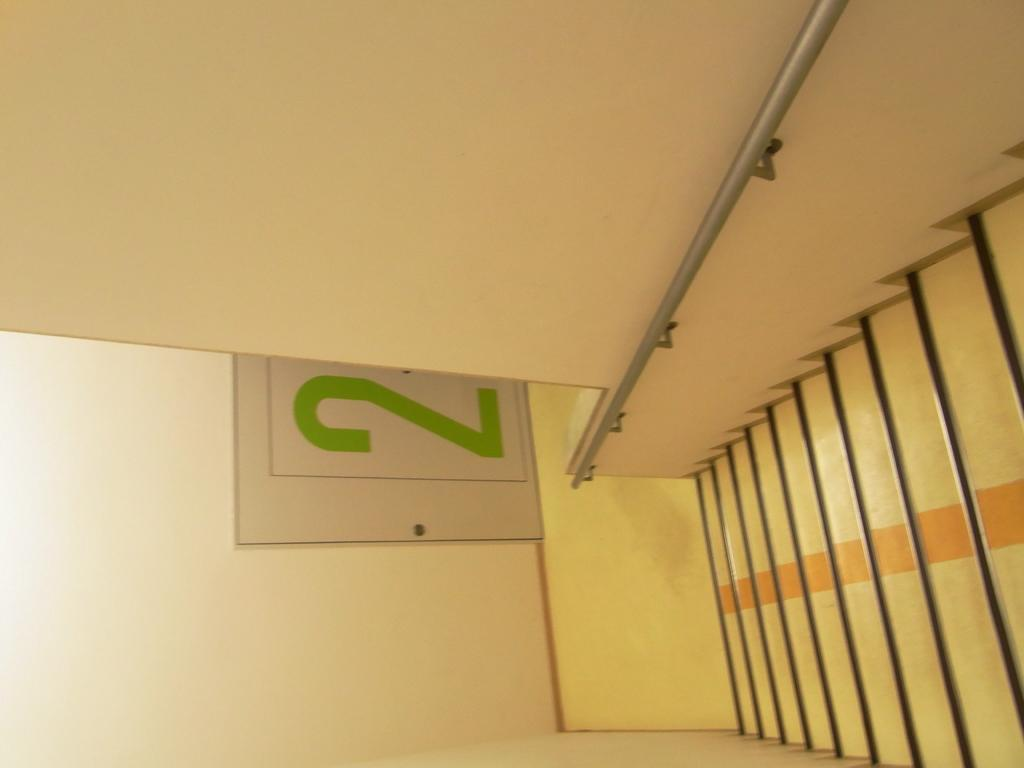What type of structure is present in the image? There is a stair in the image. Is there any support for the stair in the image? Yes, there is a handrail attached to the wall in the image. What else can be seen attached to the wall in the image? There is a board with a number on it in the image. How is the board with a number attached to the wall? The board is attached to the wall. What type of dinner is being served on the railway in the image? There is no dinner or railway present in the image; it only features a stair, handrail, and board with a number. 